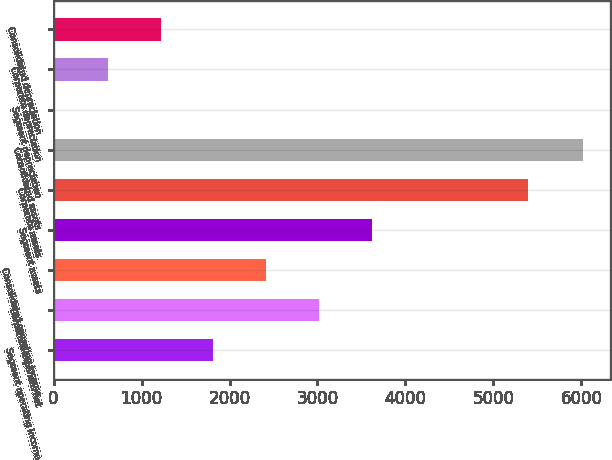<chart> <loc_0><loc_0><loc_500><loc_500><bar_chart><fcel>Segment operating income<fcel>Corporate expenses net<fcel>Consolidated operating income<fcel>Segment assets<fcel>Corporate assets<fcel>Consolidated assets<fcel>Segment depreciation<fcel>Corporate depreciation<fcel>Consolidated depreciation<nl><fcel>1817.5<fcel>3018.5<fcel>2418<fcel>3619<fcel>5390<fcel>6021<fcel>16<fcel>616.5<fcel>1217<nl></chart> 